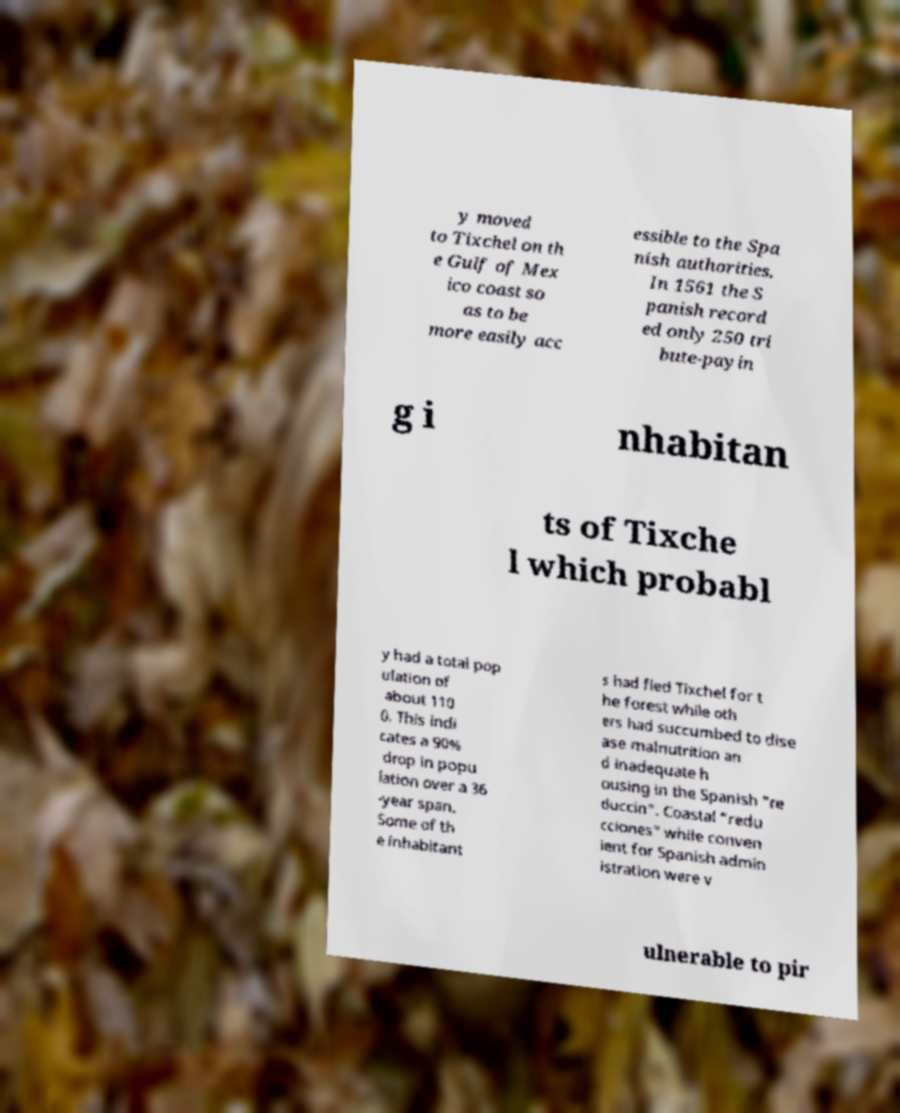Please read and relay the text visible in this image. What does it say? y moved to Tixchel on th e Gulf of Mex ico coast so as to be more easily acc essible to the Spa nish authorities. In 1561 the S panish record ed only 250 tri bute-payin g i nhabitan ts of Tixche l which probabl y had a total pop ulation of about 110 0. This indi cates a 90% drop in popu lation over a 36 -year span. Some of th e inhabitant s had fled Tixchel for t he forest while oth ers had succumbed to dise ase malnutrition an d inadequate h ousing in the Spanish "re duccin". Coastal "redu cciones" while conven ient for Spanish admin istration were v ulnerable to pir 